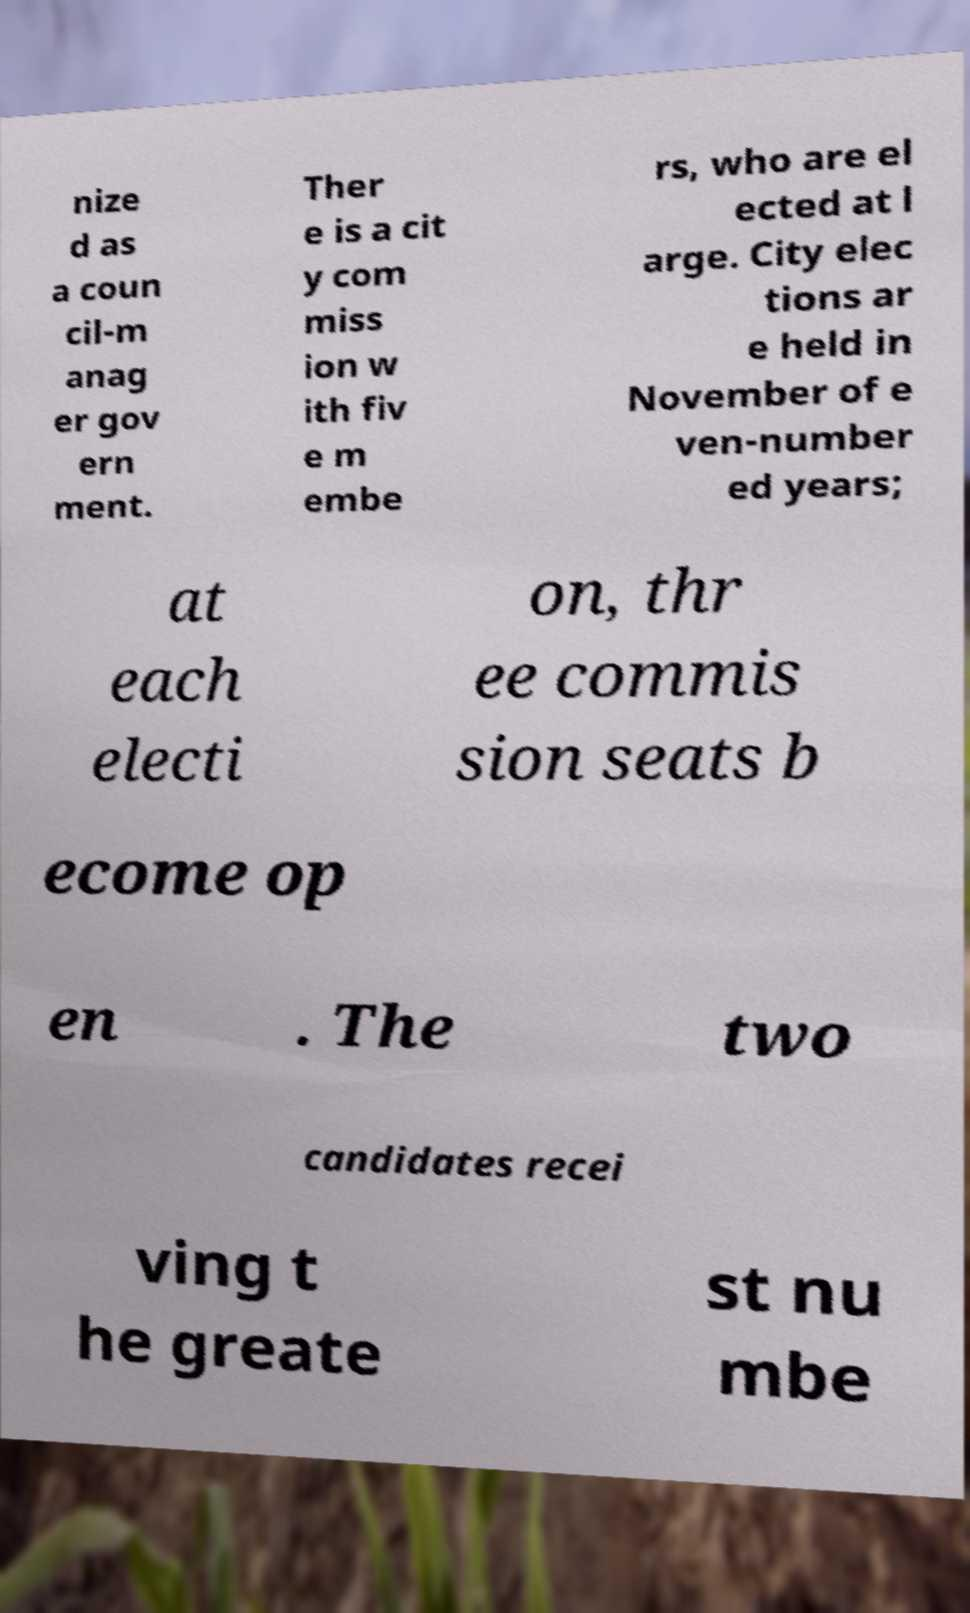Please read and relay the text visible in this image. What does it say? nize d as a coun cil-m anag er gov ern ment. Ther e is a cit y com miss ion w ith fiv e m embe rs, who are el ected at l arge. City elec tions ar e held in November of e ven-number ed years; at each electi on, thr ee commis sion seats b ecome op en . The two candidates recei ving t he greate st nu mbe 